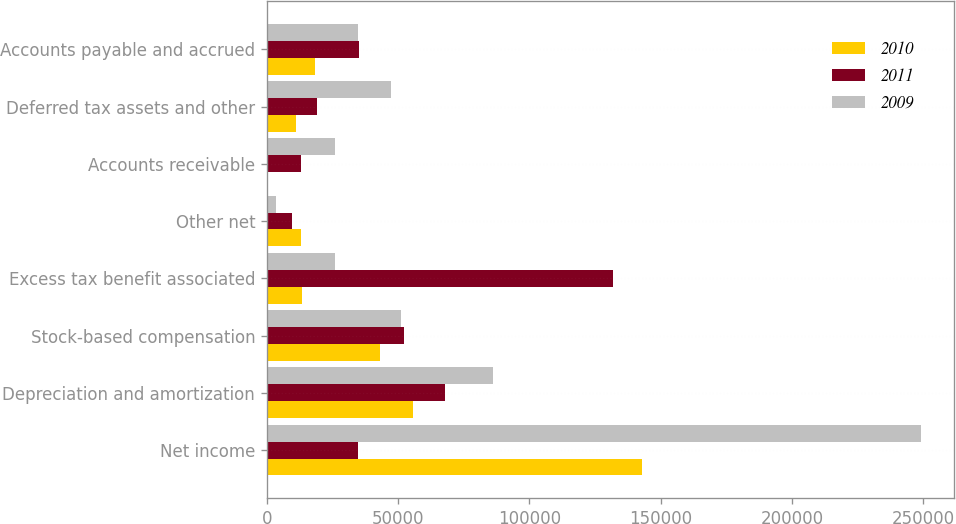Convert chart. <chart><loc_0><loc_0><loc_500><loc_500><stacked_bar_chart><ecel><fcel>Net income<fcel>Depreciation and amortization<fcel>Stock-based compensation<fcel>Excess tax benefit associated<fcel>Other net<fcel>Accounts receivable<fcel>Deferred tax assets and other<fcel>Accounts payable and accrued<nl><fcel>2010<fcel>142891<fcel>55706<fcel>43272<fcel>13420<fcel>12965<fcel>251<fcel>11043<fcel>18162<nl><fcel>2011<fcel>34545<fcel>67655<fcel>52178<fcel>131926<fcel>9474<fcel>13147<fcel>19105<fcel>34952<nl><fcel>2009<fcel>249239<fcel>86266<fcel>51166<fcel>25880<fcel>3567<fcel>25798<fcel>47418<fcel>34545<nl></chart> 